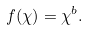Convert formula to latex. <formula><loc_0><loc_0><loc_500><loc_500>f ( \chi ) = \chi ^ { b } .</formula> 